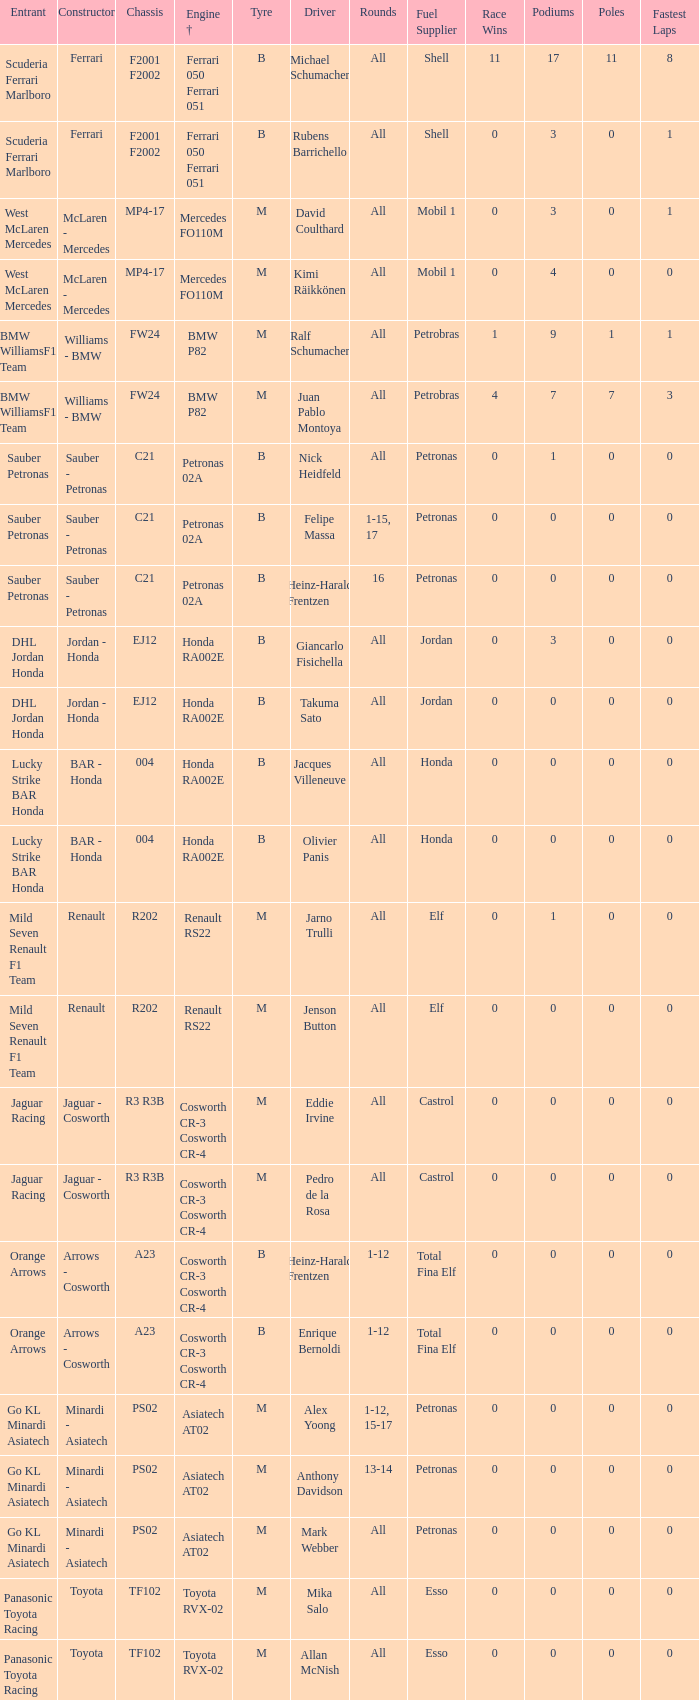What is the tyre when the engine is asiatech at02 and the driver is alex yoong? M. 